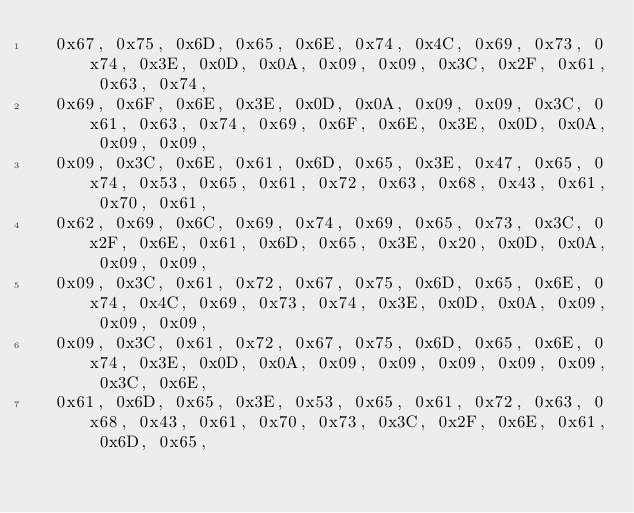<code> <loc_0><loc_0><loc_500><loc_500><_C++_>  0x67, 0x75, 0x6D, 0x65, 0x6E, 0x74, 0x4C, 0x69, 0x73, 0x74, 0x3E, 0x0D, 0x0A, 0x09, 0x09, 0x3C, 0x2F, 0x61, 0x63, 0x74, 
  0x69, 0x6F, 0x6E, 0x3E, 0x0D, 0x0A, 0x09, 0x09, 0x3C, 0x61, 0x63, 0x74, 0x69, 0x6F, 0x6E, 0x3E, 0x0D, 0x0A, 0x09, 0x09, 
  0x09, 0x3C, 0x6E, 0x61, 0x6D, 0x65, 0x3E, 0x47, 0x65, 0x74, 0x53, 0x65, 0x61, 0x72, 0x63, 0x68, 0x43, 0x61, 0x70, 0x61, 
  0x62, 0x69, 0x6C, 0x69, 0x74, 0x69, 0x65, 0x73, 0x3C, 0x2F, 0x6E, 0x61, 0x6D, 0x65, 0x3E, 0x20, 0x0D, 0x0A, 0x09, 0x09, 
  0x09, 0x3C, 0x61, 0x72, 0x67, 0x75, 0x6D, 0x65, 0x6E, 0x74, 0x4C, 0x69, 0x73, 0x74, 0x3E, 0x0D, 0x0A, 0x09, 0x09, 0x09, 
  0x09, 0x3C, 0x61, 0x72, 0x67, 0x75, 0x6D, 0x65, 0x6E, 0x74, 0x3E, 0x0D, 0x0A, 0x09, 0x09, 0x09, 0x09, 0x09, 0x3C, 0x6E, 
  0x61, 0x6D, 0x65, 0x3E, 0x53, 0x65, 0x61, 0x72, 0x63, 0x68, 0x43, 0x61, 0x70, 0x73, 0x3C, 0x2F, 0x6E, 0x61, 0x6D, 0x65, </code> 